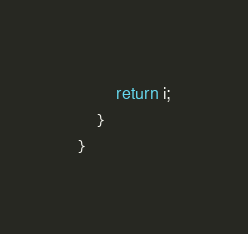<code> <loc_0><loc_0><loc_500><loc_500><_Java_>        return i;
    }
}
</code> 